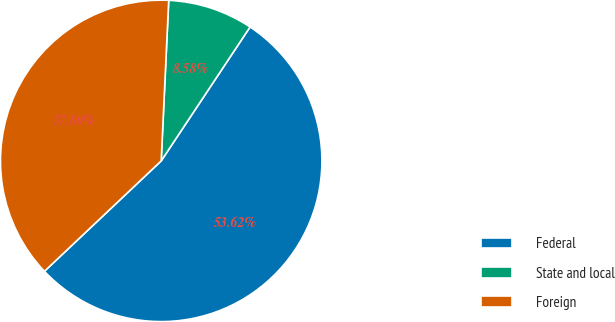Convert chart to OTSL. <chart><loc_0><loc_0><loc_500><loc_500><pie_chart><fcel>Federal<fcel>State and local<fcel>Foreign<nl><fcel>53.62%<fcel>8.58%<fcel>37.8%<nl></chart> 